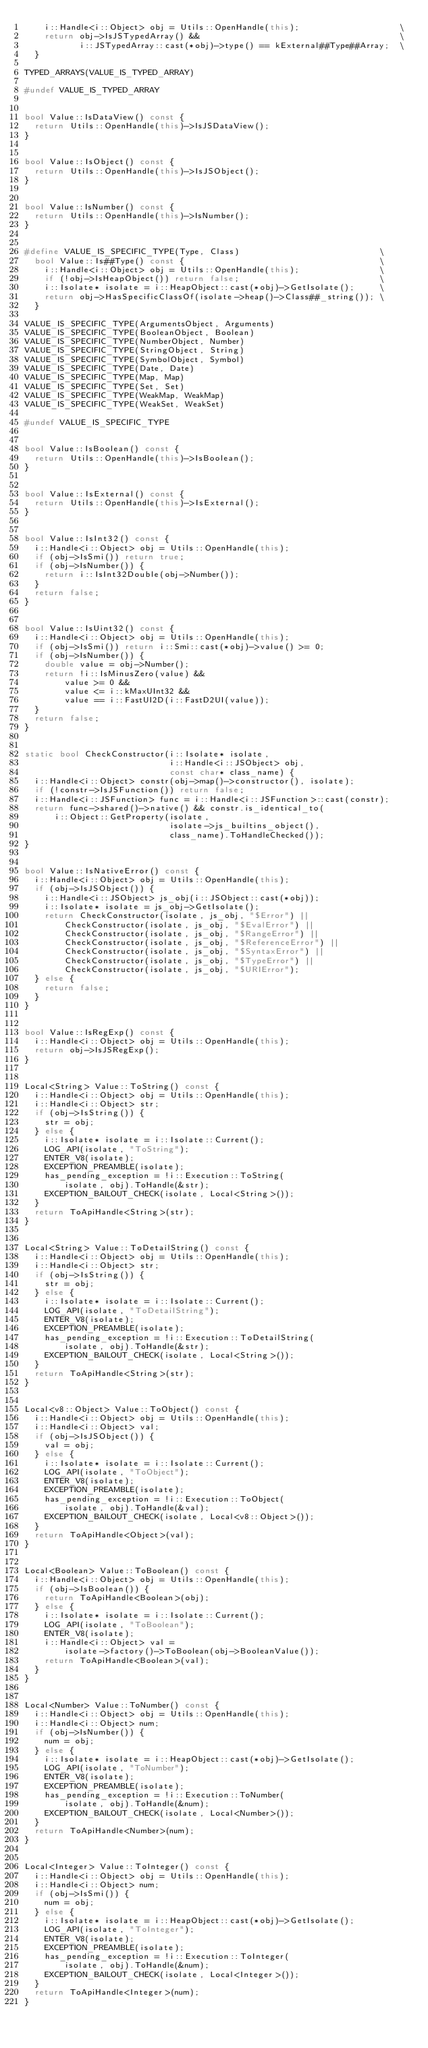Convert code to text. <code><loc_0><loc_0><loc_500><loc_500><_C++_>    i::Handle<i::Object> obj = Utils::OpenHandle(this);                    \
    return obj->IsJSTypedArray() &&                                        \
           i::JSTypedArray::cast(*obj)->type() == kExternal##Type##Array;  \
  }

TYPED_ARRAYS(VALUE_IS_TYPED_ARRAY)

#undef VALUE_IS_TYPED_ARRAY


bool Value::IsDataView() const {
  return Utils::OpenHandle(this)->IsJSDataView();
}


bool Value::IsObject() const {
  return Utils::OpenHandle(this)->IsJSObject();
}


bool Value::IsNumber() const {
  return Utils::OpenHandle(this)->IsNumber();
}


#define VALUE_IS_SPECIFIC_TYPE(Type, Class)                            \
  bool Value::Is##Type() const {                                       \
    i::Handle<i::Object> obj = Utils::OpenHandle(this);                \
    if (!obj->IsHeapObject()) return false;                            \
    i::Isolate* isolate = i::HeapObject::cast(*obj)->GetIsolate();     \
    return obj->HasSpecificClassOf(isolate->heap()->Class##_string()); \
  }

VALUE_IS_SPECIFIC_TYPE(ArgumentsObject, Arguments)
VALUE_IS_SPECIFIC_TYPE(BooleanObject, Boolean)
VALUE_IS_SPECIFIC_TYPE(NumberObject, Number)
VALUE_IS_SPECIFIC_TYPE(StringObject, String)
VALUE_IS_SPECIFIC_TYPE(SymbolObject, Symbol)
VALUE_IS_SPECIFIC_TYPE(Date, Date)
VALUE_IS_SPECIFIC_TYPE(Map, Map)
VALUE_IS_SPECIFIC_TYPE(Set, Set)
VALUE_IS_SPECIFIC_TYPE(WeakMap, WeakMap)
VALUE_IS_SPECIFIC_TYPE(WeakSet, WeakSet)

#undef VALUE_IS_SPECIFIC_TYPE


bool Value::IsBoolean() const {
  return Utils::OpenHandle(this)->IsBoolean();
}


bool Value::IsExternal() const {
  return Utils::OpenHandle(this)->IsExternal();
}


bool Value::IsInt32() const {
  i::Handle<i::Object> obj = Utils::OpenHandle(this);
  if (obj->IsSmi()) return true;
  if (obj->IsNumber()) {
    return i::IsInt32Double(obj->Number());
  }
  return false;
}


bool Value::IsUint32() const {
  i::Handle<i::Object> obj = Utils::OpenHandle(this);
  if (obj->IsSmi()) return i::Smi::cast(*obj)->value() >= 0;
  if (obj->IsNumber()) {
    double value = obj->Number();
    return !i::IsMinusZero(value) &&
        value >= 0 &&
        value <= i::kMaxUInt32 &&
        value == i::FastUI2D(i::FastD2UI(value));
  }
  return false;
}


static bool CheckConstructor(i::Isolate* isolate,
                             i::Handle<i::JSObject> obj,
                             const char* class_name) {
  i::Handle<i::Object> constr(obj->map()->constructor(), isolate);
  if (!constr->IsJSFunction()) return false;
  i::Handle<i::JSFunction> func = i::Handle<i::JSFunction>::cast(constr);
  return func->shared()->native() && constr.is_identical_to(
      i::Object::GetProperty(isolate,
                             isolate->js_builtins_object(),
                             class_name).ToHandleChecked());
}


bool Value::IsNativeError() const {
  i::Handle<i::Object> obj = Utils::OpenHandle(this);
  if (obj->IsJSObject()) {
    i::Handle<i::JSObject> js_obj(i::JSObject::cast(*obj));
    i::Isolate* isolate = js_obj->GetIsolate();
    return CheckConstructor(isolate, js_obj, "$Error") ||
        CheckConstructor(isolate, js_obj, "$EvalError") ||
        CheckConstructor(isolate, js_obj, "$RangeError") ||
        CheckConstructor(isolate, js_obj, "$ReferenceError") ||
        CheckConstructor(isolate, js_obj, "$SyntaxError") ||
        CheckConstructor(isolate, js_obj, "$TypeError") ||
        CheckConstructor(isolate, js_obj, "$URIError");
  } else {
    return false;
  }
}


bool Value::IsRegExp() const {
  i::Handle<i::Object> obj = Utils::OpenHandle(this);
  return obj->IsJSRegExp();
}


Local<String> Value::ToString() const {
  i::Handle<i::Object> obj = Utils::OpenHandle(this);
  i::Handle<i::Object> str;
  if (obj->IsString()) {
    str = obj;
  } else {
    i::Isolate* isolate = i::Isolate::Current();
    LOG_API(isolate, "ToString");
    ENTER_V8(isolate);
    EXCEPTION_PREAMBLE(isolate);
    has_pending_exception = !i::Execution::ToString(
        isolate, obj).ToHandle(&str);
    EXCEPTION_BAILOUT_CHECK(isolate, Local<String>());
  }
  return ToApiHandle<String>(str);
}


Local<String> Value::ToDetailString() const {
  i::Handle<i::Object> obj = Utils::OpenHandle(this);
  i::Handle<i::Object> str;
  if (obj->IsString()) {
    str = obj;
  } else {
    i::Isolate* isolate = i::Isolate::Current();
    LOG_API(isolate, "ToDetailString");
    ENTER_V8(isolate);
    EXCEPTION_PREAMBLE(isolate);
    has_pending_exception = !i::Execution::ToDetailString(
        isolate, obj).ToHandle(&str);
    EXCEPTION_BAILOUT_CHECK(isolate, Local<String>());
  }
  return ToApiHandle<String>(str);
}


Local<v8::Object> Value::ToObject() const {
  i::Handle<i::Object> obj = Utils::OpenHandle(this);
  i::Handle<i::Object> val;
  if (obj->IsJSObject()) {
    val = obj;
  } else {
    i::Isolate* isolate = i::Isolate::Current();
    LOG_API(isolate, "ToObject");
    ENTER_V8(isolate);
    EXCEPTION_PREAMBLE(isolate);
    has_pending_exception = !i::Execution::ToObject(
        isolate, obj).ToHandle(&val);
    EXCEPTION_BAILOUT_CHECK(isolate, Local<v8::Object>());
  }
  return ToApiHandle<Object>(val);
}


Local<Boolean> Value::ToBoolean() const {
  i::Handle<i::Object> obj = Utils::OpenHandle(this);
  if (obj->IsBoolean()) {
    return ToApiHandle<Boolean>(obj);
  } else {
    i::Isolate* isolate = i::Isolate::Current();
    LOG_API(isolate, "ToBoolean");
    ENTER_V8(isolate);
    i::Handle<i::Object> val =
        isolate->factory()->ToBoolean(obj->BooleanValue());
    return ToApiHandle<Boolean>(val);
  }
}


Local<Number> Value::ToNumber() const {
  i::Handle<i::Object> obj = Utils::OpenHandle(this);
  i::Handle<i::Object> num;
  if (obj->IsNumber()) {
    num = obj;
  } else {
    i::Isolate* isolate = i::HeapObject::cast(*obj)->GetIsolate();
    LOG_API(isolate, "ToNumber");
    ENTER_V8(isolate);
    EXCEPTION_PREAMBLE(isolate);
    has_pending_exception = !i::Execution::ToNumber(
        isolate, obj).ToHandle(&num);
    EXCEPTION_BAILOUT_CHECK(isolate, Local<Number>());
  }
  return ToApiHandle<Number>(num);
}


Local<Integer> Value::ToInteger() const {
  i::Handle<i::Object> obj = Utils::OpenHandle(this);
  i::Handle<i::Object> num;
  if (obj->IsSmi()) {
    num = obj;
  } else {
    i::Isolate* isolate = i::HeapObject::cast(*obj)->GetIsolate();
    LOG_API(isolate, "ToInteger");
    ENTER_V8(isolate);
    EXCEPTION_PREAMBLE(isolate);
    has_pending_exception = !i::Execution::ToInteger(
        isolate, obj).ToHandle(&num);
    EXCEPTION_BAILOUT_CHECK(isolate, Local<Integer>());
  }
  return ToApiHandle<Integer>(num);
}

</code> 